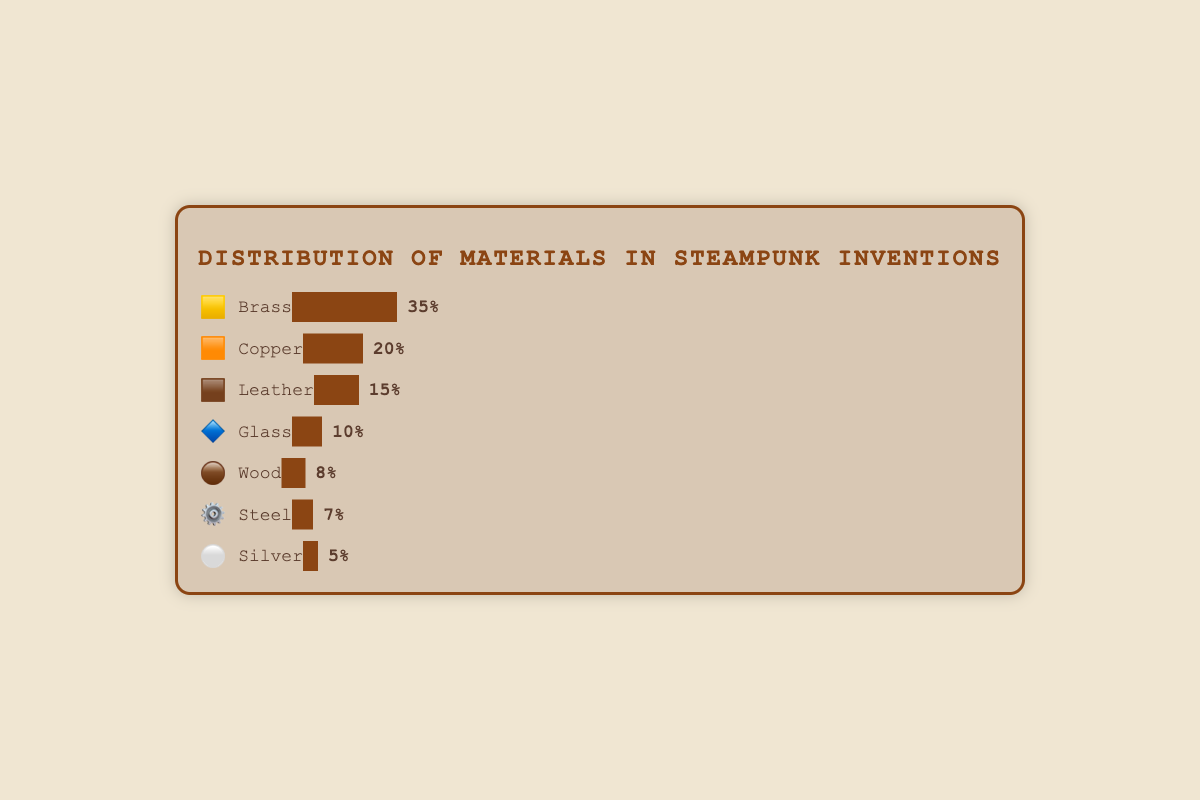What material has the highest percentage? The bar representing Brass has the largest width and shows 35%, which is the highest percentage among all materials.
Answer: Brass Which material is represented by the 🟧 emoji? Looking at the chart, the 🟧 emoji is next to the material Copper.
Answer: Copper What is the combined percentage of Leather (🟫) and Glass (🔷)? Leather has 15% and Glass has 10%. The combined percentage is 15% + 10% = 25%.
Answer: 25% Which material has a higher percentage: Wood (🟤) or Steel (⚙️)? Wood has 8% while Steel has 7%. Therefore, Wood has a higher percentage than Steel.
Answer: Wood How many materials have a percentage below 10%? From the chart, Wood (8%), Steel (7%), and Silver (5%) each have percentages below 10%. Thus, there are 3 materials.
Answer: 3 What is the sum of the percentages of all the materials? Adding the percentages: Brass (35%) + Copper (20%) + Leather (15%) + Glass (10%) + Wood (8%) + Steel (7%) + Silver (5%) = 100%.
Answer: 100% Which material has the smallest percentage and what is it? The smallest percentage is 5%, which corresponds to Silver (⚪) in the chart.
Answer: Silver, 5% Is the percentage of Copper (🟧) greater than twice the percentage of Silver (⚪)? Twice the percentage of Silver is 2 * 5% = 10%. The percentage of Copper is 20%, which is greater than 10%.
Answer: Yes What is the average percentage of Brass (🟨), Leather (🟫), and Steel (⚙️)? Sum of percentages: Brass (35%) + Leather (15%) + Steel (7%) = 57%. Dividing by the number of materials: 57 / 3 = 19%.
Answer: 19% Which material is represented by the 🔷 emoji and what is its percentage? The 🔷 emoji is next to Glass in the chart, indicating a percentage of 10%.
Answer: Glass, 10% 